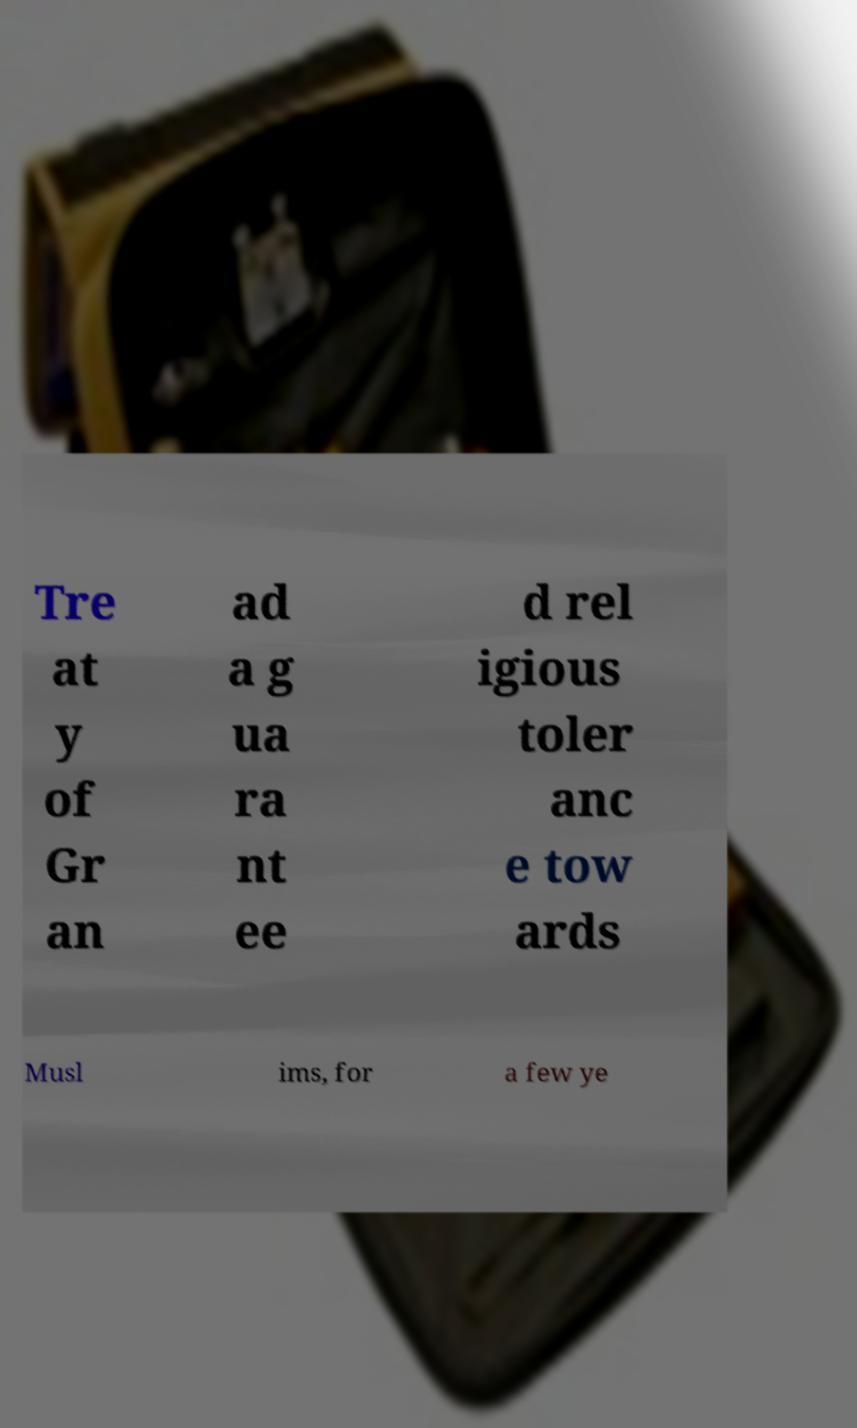For documentation purposes, I need the text within this image transcribed. Could you provide that? Tre at y of Gr an ad a g ua ra nt ee d rel igious toler anc e tow ards Musl ims, for a few ye 